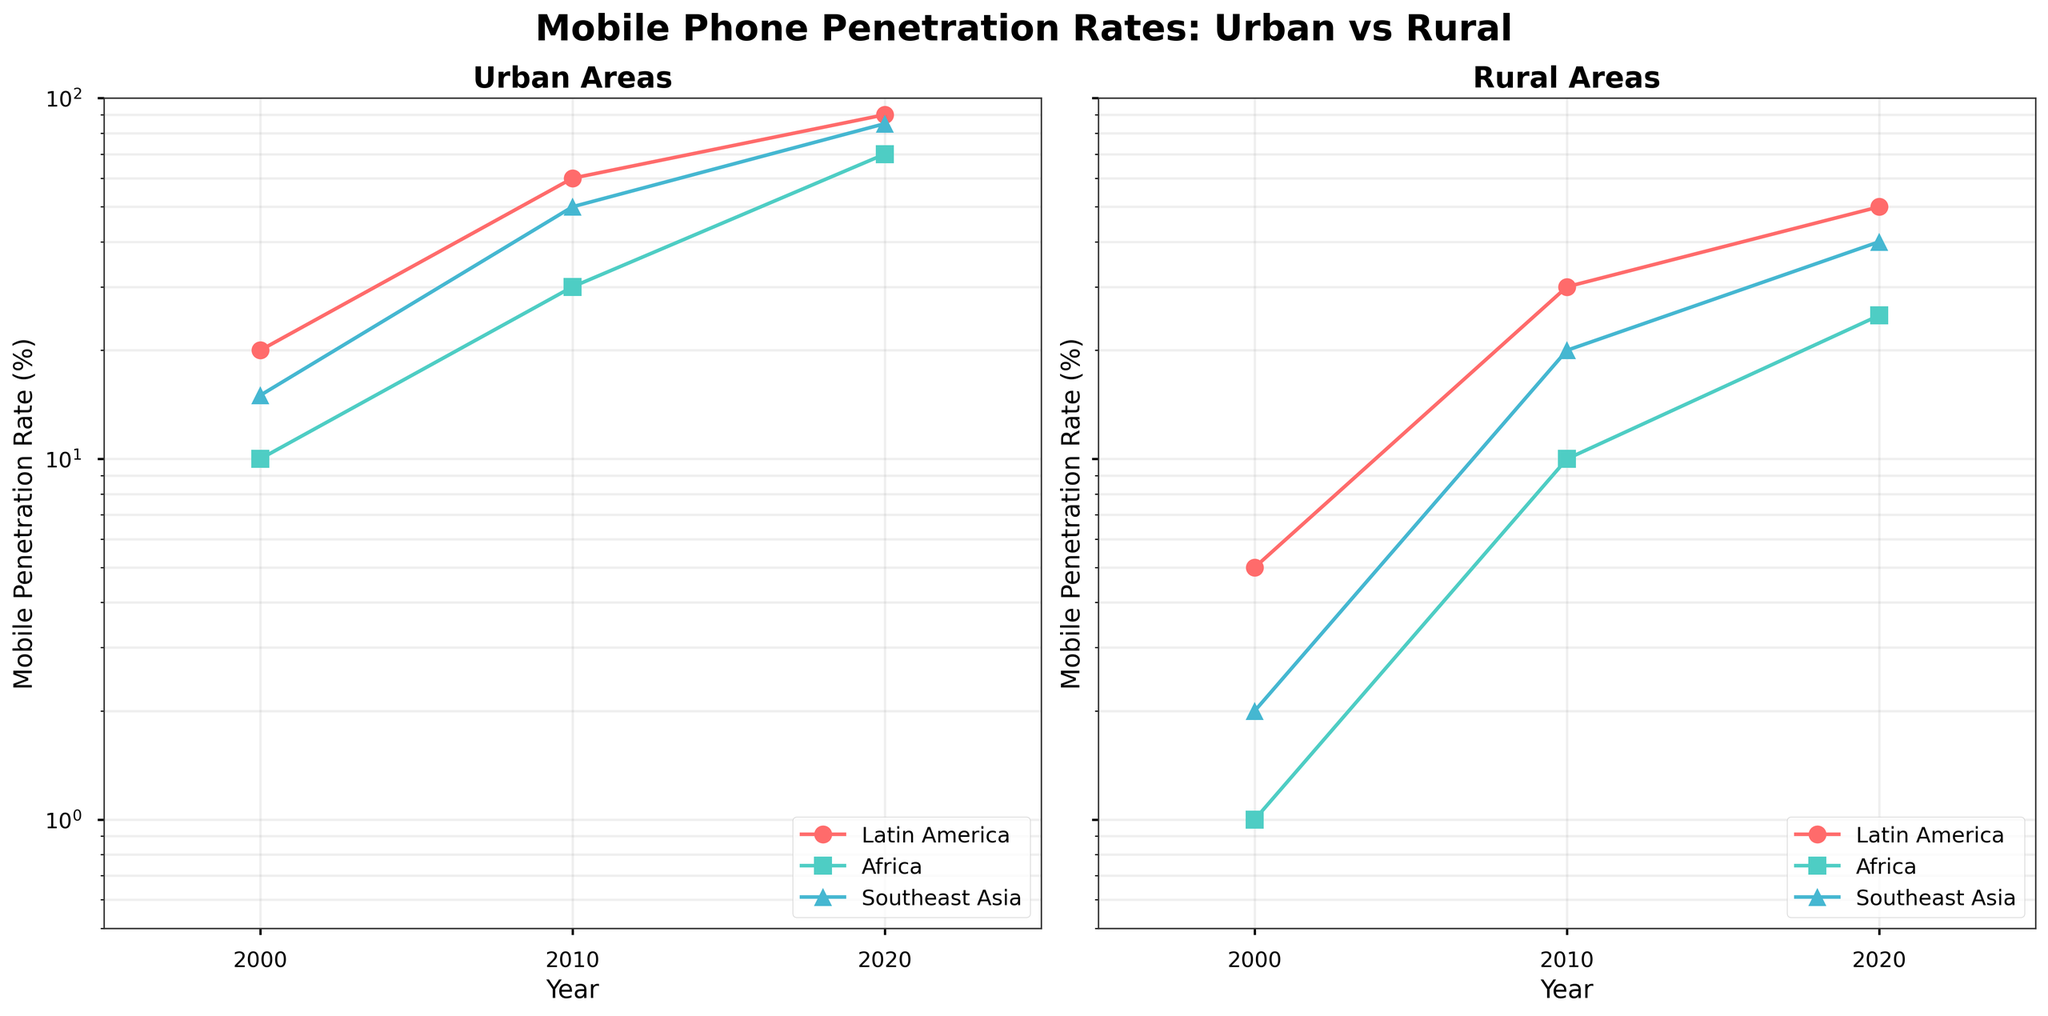What is the title of the figure? The title of the figure is located at the top center of the figure, and it helps to understand what the entire data representation is about
Answer: Mobile Phone Penetration Rates: Urban vs Rural How many regions are represented in this figure? By looking at the legend in the figure, we can see three different regions represented by different colors and markers
Answer: Three What is the highest urban mobile penetration rate for Southeast Asia in 2020? Locate the urban subplot and look for Southeast Asia's data in the year 2020, which is represented by the corresponding color and marker
Answer: 85% Which region had the lowest rural mobile penetration rate in 2000? Locate the rural subplot, look at the data points for the year 2000, and compare the values across the three regions
Answer: Africa How did the urban mobile penetration rate change for Latin America from 2000 to 2020? Observe Latin America's data points in the urban subplot and note down the penetration rates in 2000 and 2020, then calculate the difference
Answer: Increased by 70% Between 2010 and 2020, which region had the greatest increase in rural mobile penetration? By comparing the rural penetration rates of all regions between these years, identify the one with the largest difference
Answer: Southeast Asia Compare urban and rural mobile penetration rates for Africa in 2020. Which one is higher? Locate Africa’s data points for 2020 in both the urban and rural subplots and compare their values
Answer: Urban mobile penetration rate What trend can be observed in rural mobile penetration rates from 2000 to 2020? Observe the direction and magnitude of data points in the rural subplot across these years to interpret the overall trend
Answer: Increasing trend What is the range of urban mobile penetration rates in 2010 across all regions? Identify all the data points for 2010 in the urban subplot and calculate the range by subtracting the smallest value from the largest value
Answer: 60% (from 30% in Africa to 90% in Latin America) How did the rural mobile penetration rate in Southeast Asia in 2020 compare to the urban rate in Africa in 2020? Identify the rural penetration rate for Southeast Asia and the urban penetration rate for Africa in 2020, then compare the two values
Answer: Southeast Asia's rural rate was higher 